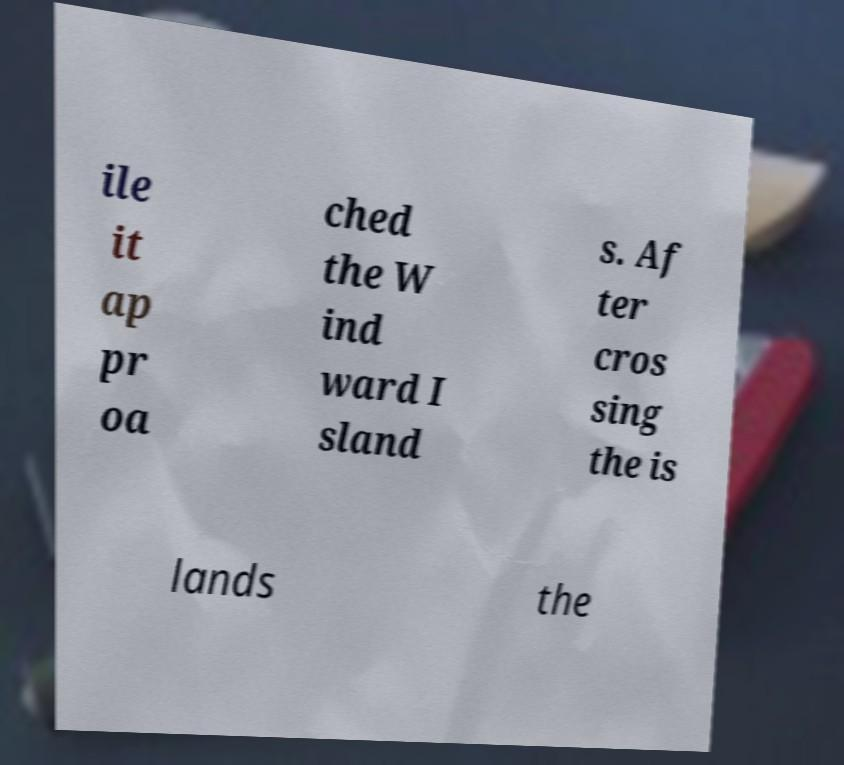Please read and relay the text visible in this image. What does it say? ile it ap pr oa ched the W ind ward I sland s. Af ter cros sing the is lands the 